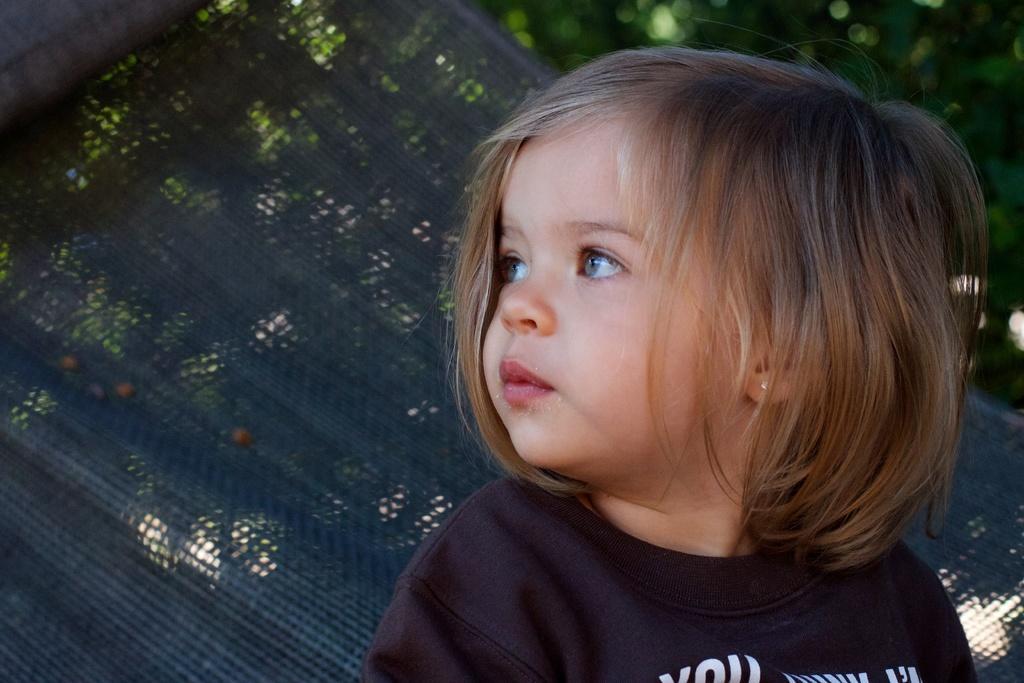How would you summarize this image in a sentence or two? In this image we can see a child wearing black color t-shirt is sitting on the hanging swing. The background of the image is slightly blurred, where we can see the trees 